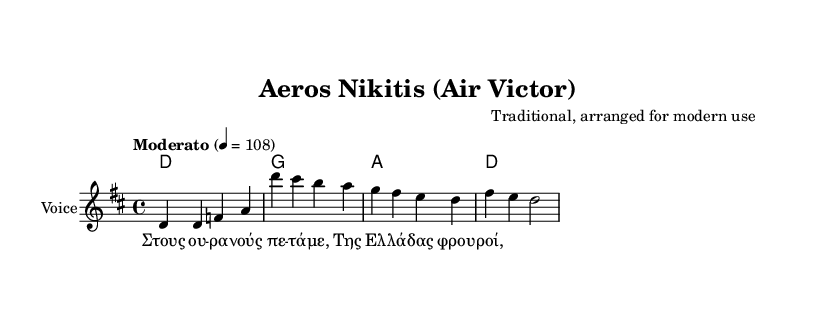What is the key signature of this music? The key signature is D major, which has two sharps (F# and C#). This can be determined by looking at the specific notation at the beginning of the sheet music.
Answer: D major What is the time signature of this piece? The time signature is 4/4, as indicated at the beginning of the music, which means there are four beats in each measure, and the quarter note gets one beat.
Answer: 4/4 What is the tempo marking for this song? The tempo marking is "Moderato" set at quarter note equals 108 beats per minute, which can be found in the tempo indication at the start of the score.
Answer: Moderato How many measures are in the staff of the melody? There are four measures, which can be counted by looking at how the notes and bars are organized in the sheet music. Each group of notes separated by the vertical lines represents a measure.
Answer: Four What is the title of the song? The title, "Aeros Nikitis (Air Victor)," is located in the header of the sheet music, indicating the song's name.
Answer: Aeros Nikitis (Air Victor) Who is the composer of this arrangement? The composer is listed as "Traditional, arranged for modern use," which is directly stated in the header section of the sheet music.
Answer: Traditional, arranged for modern use What is the first lyric of the song? The first lyric is "Στους ου -- ρα --νούς πε -- τά -- με," which can be identified from the lyrics printed below the melody notes.
Answer: Στους ου -- ρα --νούς πε -- τά -- με 